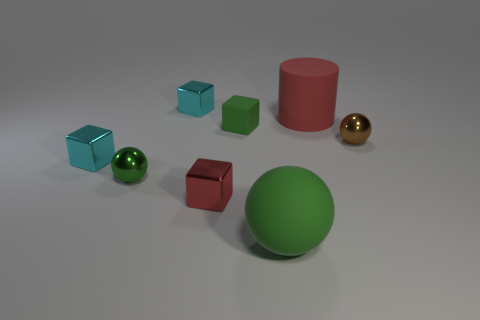The big matte thing in front of the tiny matte block that is behind the red shiny thing is what shape?
Offer a terse response. Sphere. What size is the shiny ball on the right side of the red object that is left of the large cylinder?
Offer a very short reply. Small. There is a tiny ball that is right of the cylinder; what is its color?
Your response must be concise. Brown. There is a sphere that is the same material as the cylinder; what is its size?
Your response must be concise. Large. What number of other tiny brown objects are the same shape as the tiny brown object?
Your response must be concise. 0. There is a thing that is the same size as the matte sphere; what is its material?
Provide a succinct answer. Rubber. Is there a tiny thing made of the same material as the cylinder?
Offer a very short reply. Yes. There is a object that is in front of the rubber cylinder and to the right of the large ball; what color is it?
Your answer should be compact. Brown. What number of other things are there of the same color as the big cylinder?
Keep it short and to the point. 1. There is a red thing on the left side of the tiny green thing that is behind the brown shiny sphere that is to the right of the large matte sphere; what is it made of?
Your answer should be compact. Metal. 